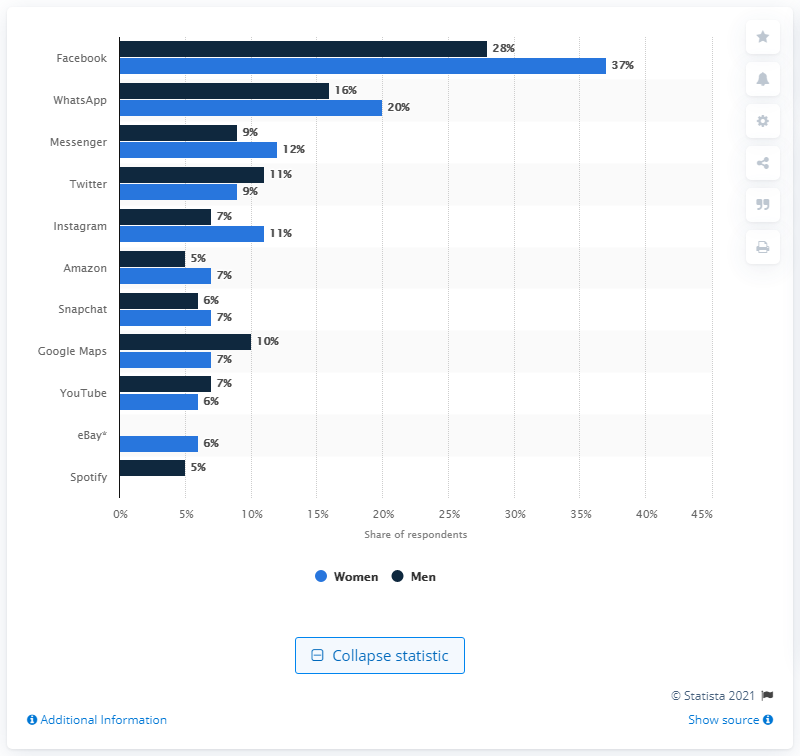Point out several critical features in this image. Approximately 9% of men use Messenger. 